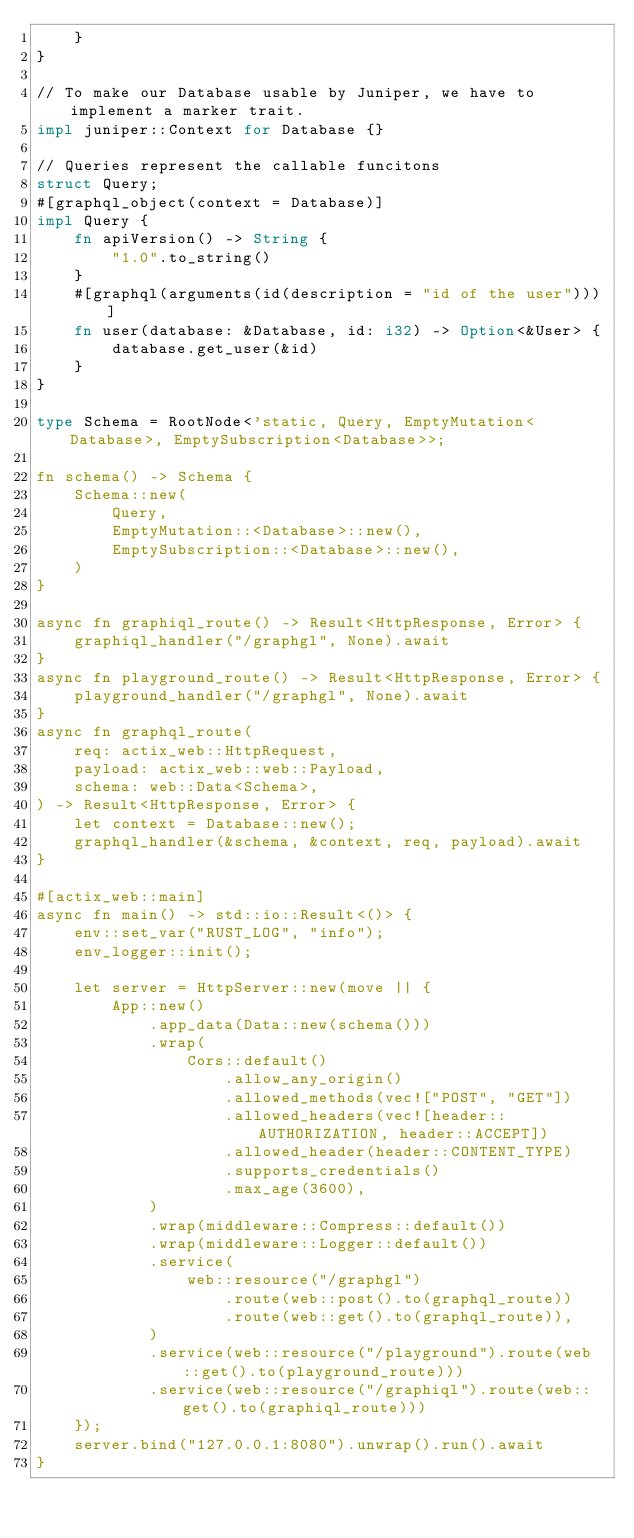<code> <loc_0><loc_0><loc_500><loc_500><_Rust_>    }
}

// To make our Database usable by Juniper, we have to implement a marker trait.
impl juniper::Context for Database {}

// Queries represent the callable funcitons
struct Query;
#[graphql_object(context = Database)]
impl Query {
    fn apiVersion() -> String {
        "1.0".to_string()
    }
    #[graphql(arguments(id(description = "id of the user")))]
    fn user(database: &Database, id: i32) -> Option<&User> {
        database.get_user(&id)
    }
}

type Schema = RootNode<'static, Query, EmptyMutation<Database>, EmptySubscription<Database>>;

fn schema() -> Schema {
    Schema::new(
        Query,
        EmptyMutation::<Database>::new(),
        EmptySubscription::<Database>::new(),
    )
}

async fn graphiql_route() -> Result<HttpResponse, Error> {
    graphiql_handler("/graphgl", None).await
}
async fn playground_route() -> Result<HttpResponse, Error> {
    playground_handler("/graphgl", None).await
}
async fn graphql_route(
    req: actix_web::HttpRequest,
    payload: actix_web::web::Payload,
    schema: web::Data<Schema>,
) -> Result<HttpResponse, Error> {
    let context = Database::new();
    graphql_handler(&schema, &context, req, payload).await
}

#[actix_web::main]
async fn main() -> std::io::Result<()> {
    env::set_var("RUST_LOG", "info");
    env_logger::init();

    let server = HttpServer::new(move || {
        App::new()
            .app_data(Data::new(schema()))
            .wrap(
                Cors::default()
                    .allow_any_origin()
                    .allowed_methods(vec!["POST", "GET"])
                    .allowed_headers(vec![header::AUTHORIZATION, header::ACCEPT])
                    .allowed_header(header::CONTENT_TYPE)
                    .supports_credentials()
                    .max_age(3600),
            )
            .wrap(middleware::Compress::default())
            .wrap(middleware::Logger::default())
            .service(
                web::resource("/graphgl")
                    .route(web::post().to(graphql_route))
                    .route(web::get().to(graphql_route)),
            )
            .service(web::resource("/playground").route(web::get().to(playground_route)))
            .service(web::resource("/graphiql").route(web::get().to(graphiql_route)))
    });
    server.bind("127.0.0.1:8080").unwrap().run().await
}</code> 